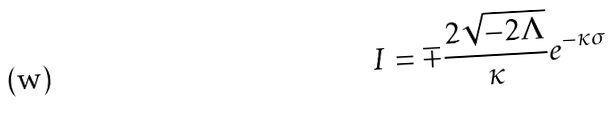<formula> <loc_0><loc_0><loc_500><loc_500>I = \mp \frac { 2 \sqrt { - 2 \Lambda } } { \kappa } e ^ { - \kappa \sigma }</formula> 